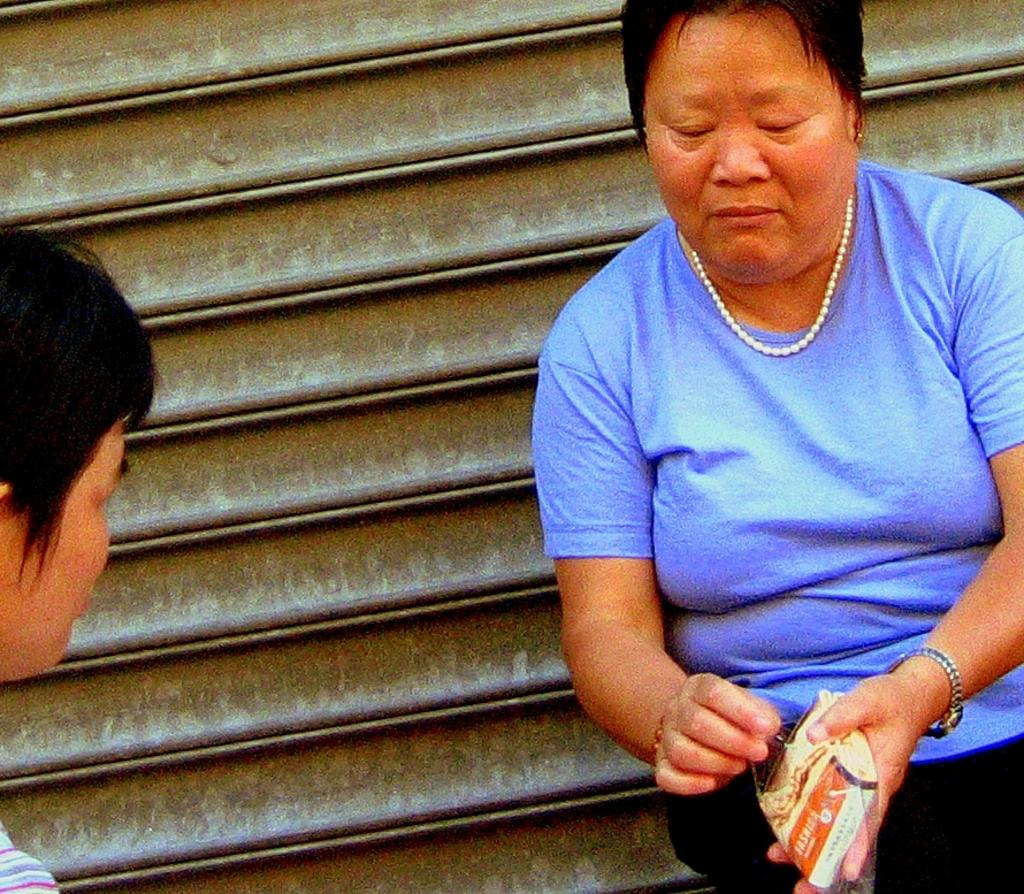What is the main subject in the center of the image? There is a woman sitting in the center of the image. What is the woman holding in the image? The woman is holding an object. Can you describe the person on the left side of the image? There is a person on the left side of the image. What can be seen in the background of the image? There is a shutter in the background of the image. How does the woman push the stage in the image? There is no stage present in the image, and the woman is not pushing anything. 